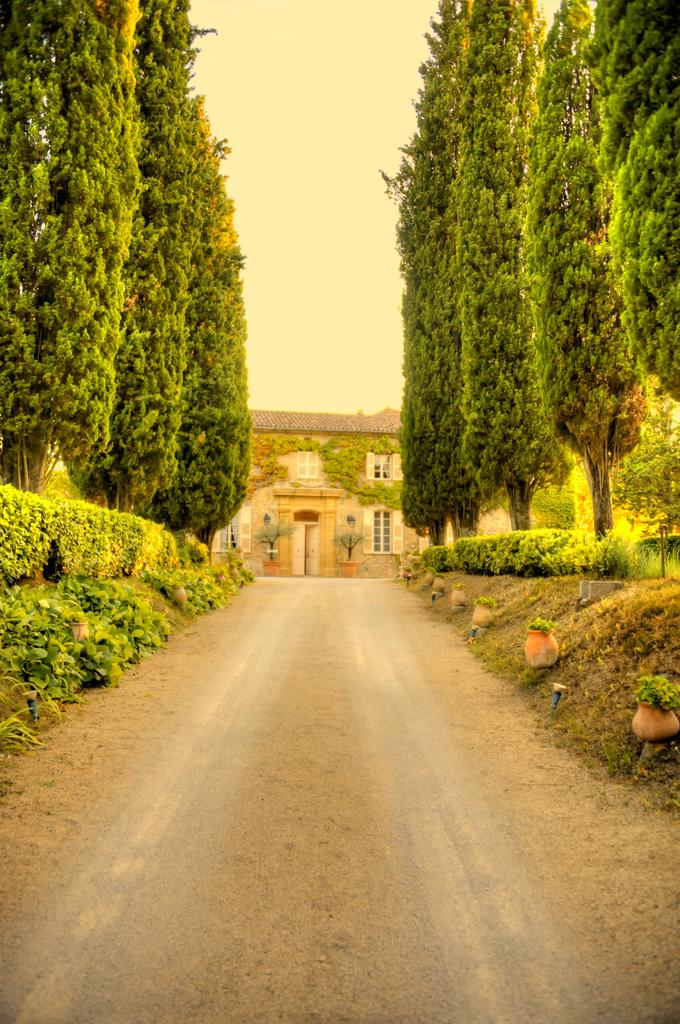What is the main subject of the image? The main subject of the image is a house. Can you describe the house in the image? The house has windows, a door, and walls. What other objects or elements can be seen in the image? There are pots, trees, bushes, a road, and sky visible in the image. What type of berry is growing on the quince tree in the image? There is no berry or quince tree present in the image. 